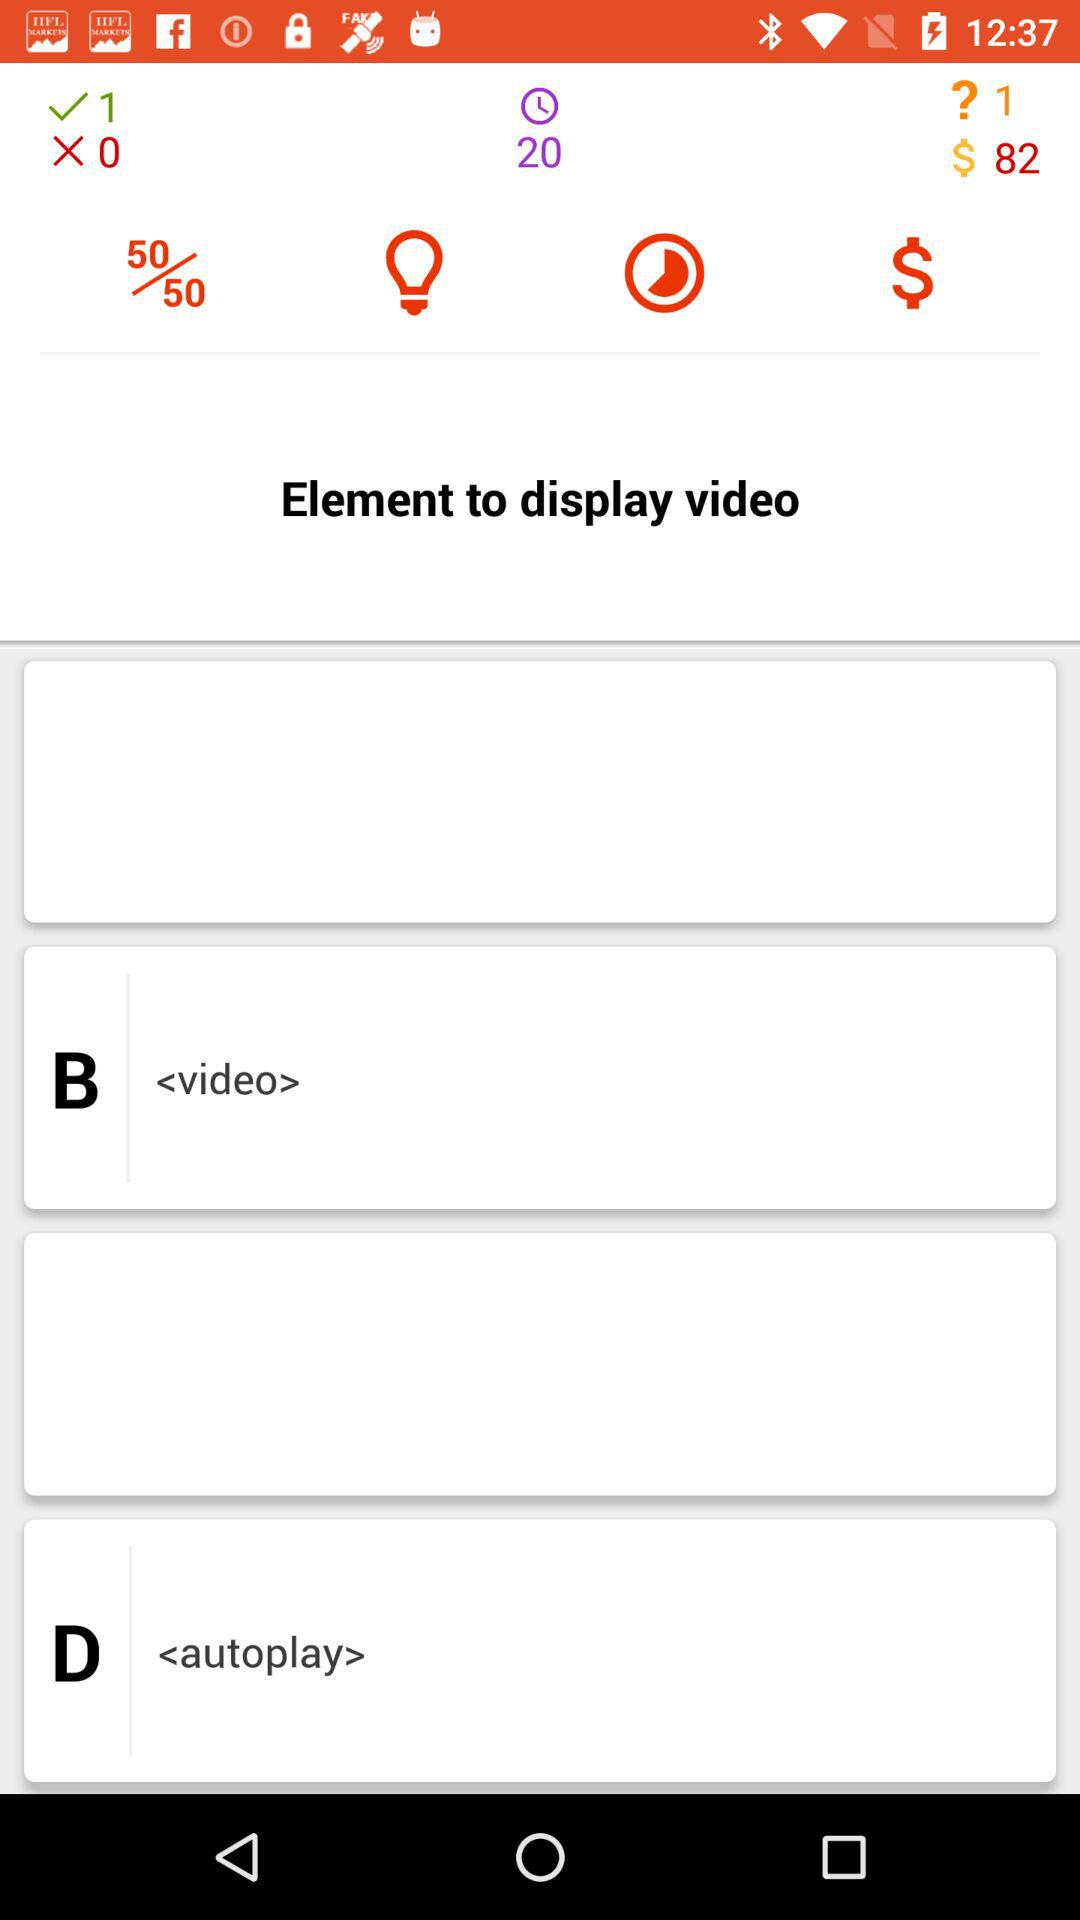Is any option selected?
When the provided information is insufficient, respond with <no answer>. <no answer> 